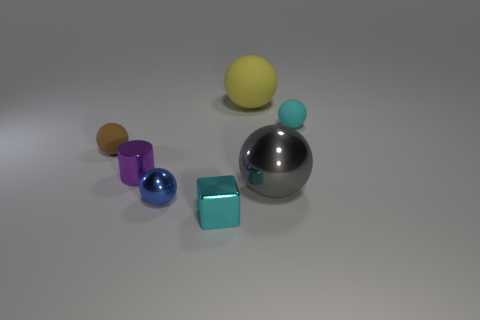Subtract all gray balls. How many balls are left? 4 Subtract all small cyan rubber spheres. How many spheres are left? 4 Subtract all red blocks. Subtract all red cylinders. How many blocks are left? 1 Add 1 small cyan matte things. How many objects exist? 8 Subtract all cylinders. How many objects are left? 6 Add 1 big gray balls. How many big gray balls exist? 2 Subtract 0 blue blocks. How many objects are left? 7 Subtract all cyan cubes. Subtract all metallic cubes. How many objects are left? 5 Add 6 yellow spheres. How many yellow spheres are left? 7 